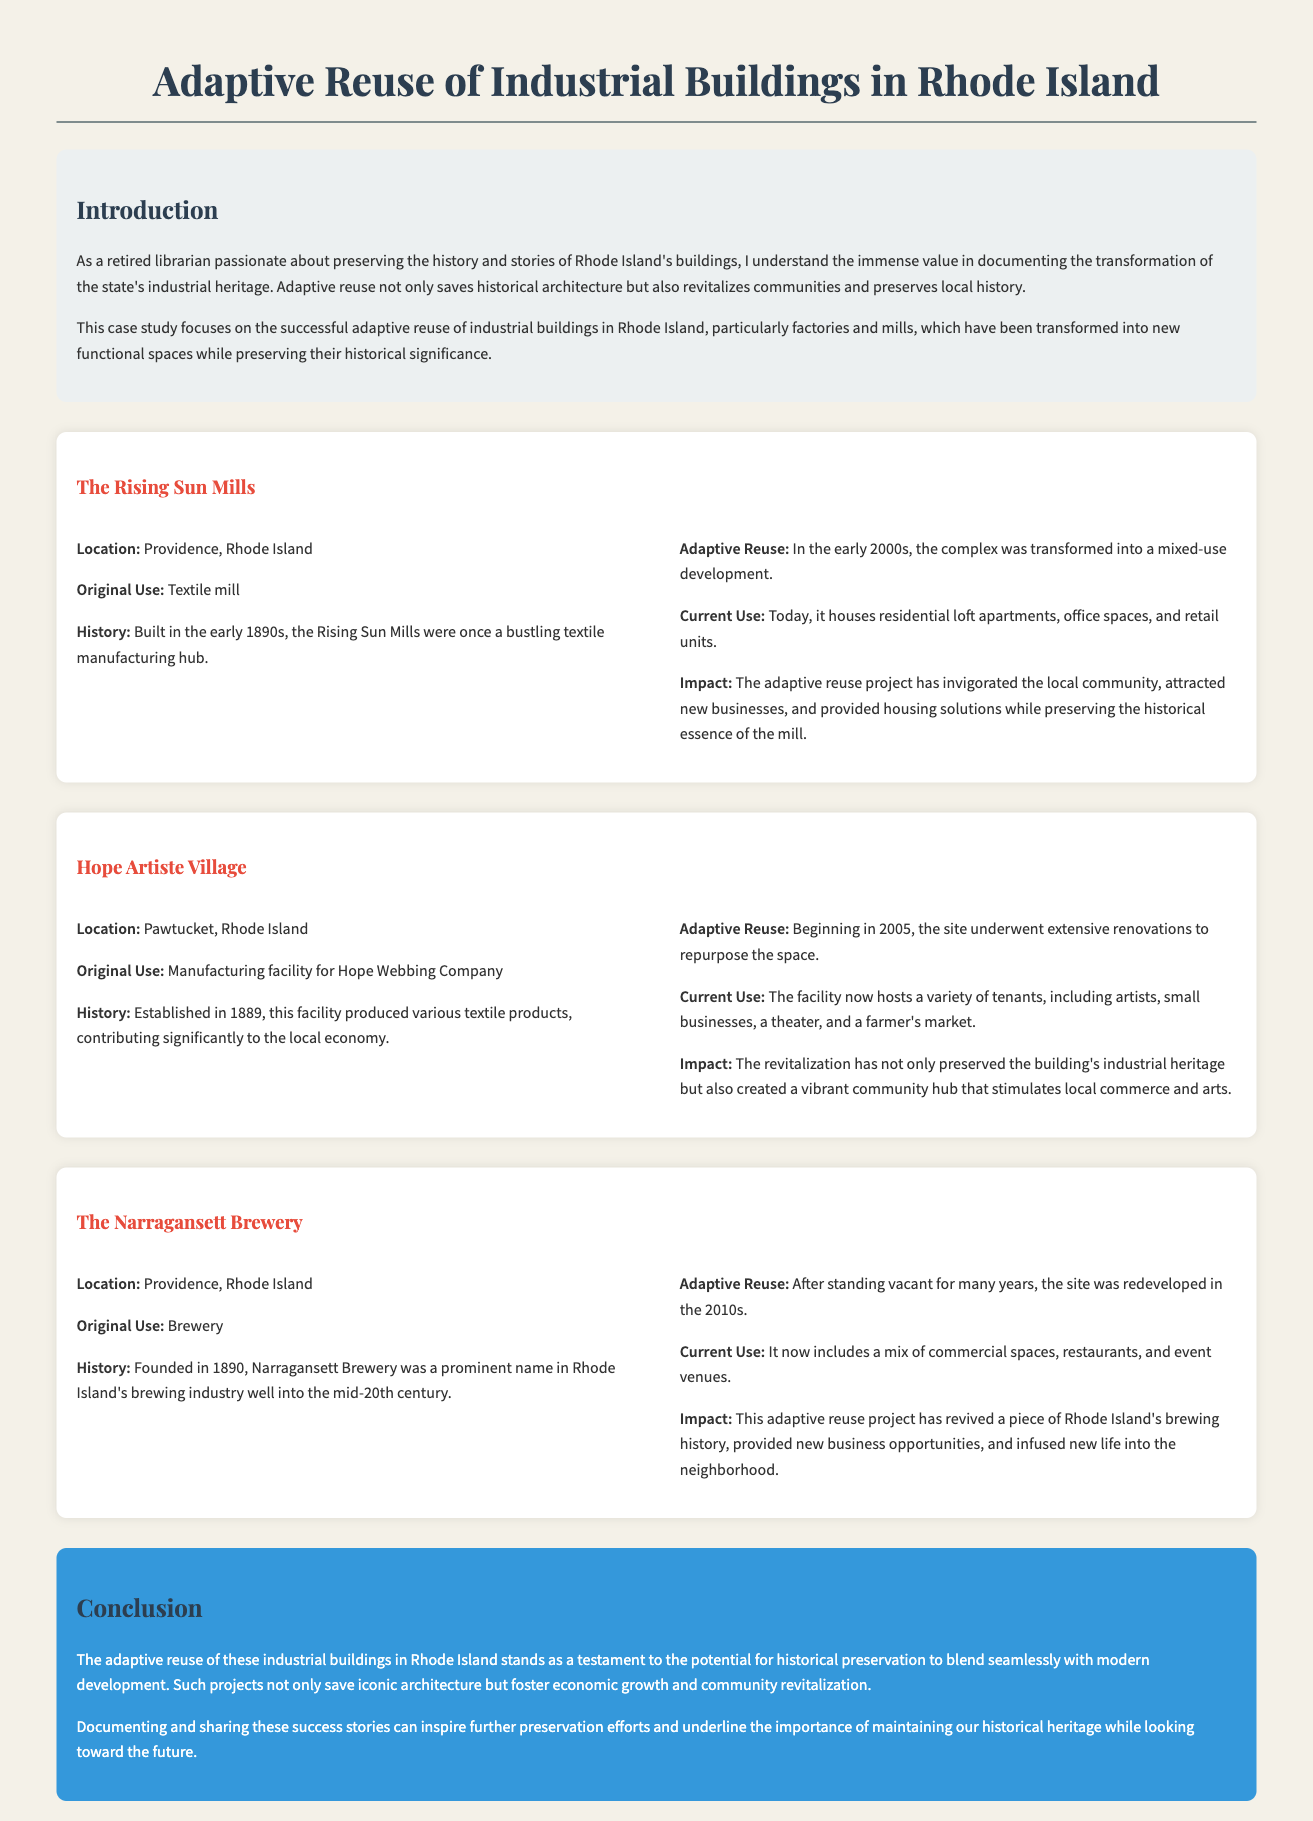What is the original use of Rising Sun Mills? The original use of Rising Sun Mills is stated as a textile mill in the document.
Answer: Textile mill What year was the Hope Artiste Village established? The Hope Artiste Village was established in 1889, according to the historical context in the case study.
Answer: 1889 What is the current use of the Narragansett Brewery? The current use of the Narragansett Brewery includes a mix of commercial spaces, restaurants, and event venues as mentioned in the document.
Answer: Commercial spaces, restaurants, and event venues What impact did the Rising Sun Mills adaptive reuse project have? The document states that the adaptive reuse project invigorated the local community and attracted new businesses.
Answer: Invigorated the local community When did renovations begin for Hope Artiste Village? The renovations for Hope Artiste Village began in 2005, as noted in the case study.
Answer: 2005 What type of building is the Rising Sun Mills? The type of building is indicated as a mill in the case study.
Answer: Mill What is a significant benefit of adaptive reuse projects described in the conclusion? The conclusion highlights that adaptive reuse projects foster economic growth.
Answer: Economic growth What does the case study aim to inspire? The case study aims to inspire further preservation efforts, as stated in the conclusion.
Answer: Further preservation efforts 